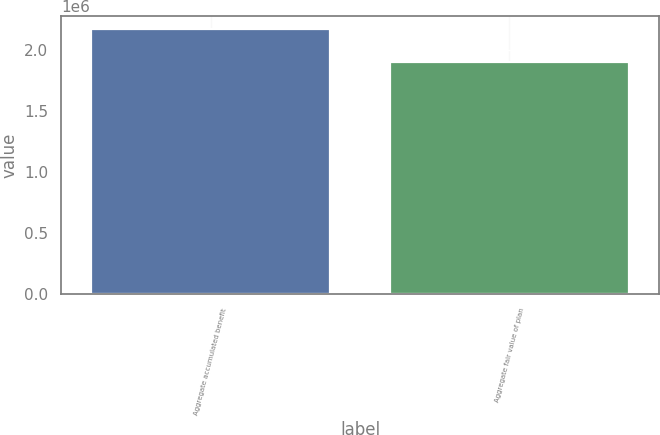<chart> <loc_0><loc_0><loc_500><loc_500><bar_chart><fcel>Aggregate accumulated benefit<fcel>Aggregate fair value of plan<nl><fcel>2.16722e+06<fcel>1.89646e+06<nl></chart> 